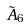<formula> <loc_0><loc_0><loc_500><loc_500>\tilde { A } _ { 6 }</formula> 